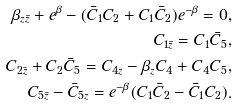Convert formula to latex. <formula><loc_0><loc_0><loc_500><loc_500>\beta _ { z \bar { z } } + e ^ { \beta } - ( \bar { C } _ { 1 } C _ { 2 } + C _ { 1 } \bar { C } _ { 2 } ) e ^ { - \beta } = 0 , \\ C _ { 1 \bar { z } } = C _ { 1 } \bar { C } _ { 5 } , \\ C _ { 2 \bar { z } } + C _ { 2 } \bar { C } _ { 5 } = C _ { 4 z } - \beta _ { z } C _ { 4 } + C _ { 4 } C _ { 5 } , \\ C _ { 5 \bar { z } } - \bar { C } _ { 5 z } = e ^ { - \beta } ( C _ { 1 } \bar { C } _ { 2 } - \bar { C } _ { 1 } C _ { 2 } ) .</formula> 